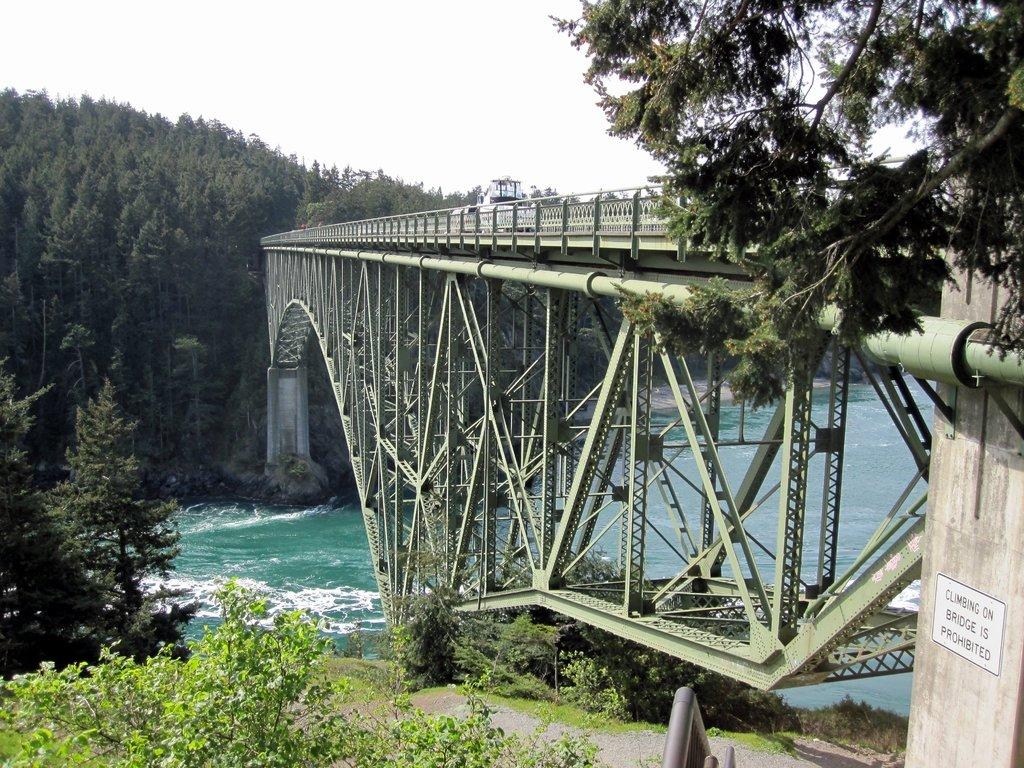What type of structure can be seen in the image? There is a bridge in the image. What is on the wall in the image? There is a poster on a wall in the image. What type of vegetation is present in the image? There are plants and trees in the image. What type of ground surface is visible in the image? There is grass in the image. What natural element is visible in the image? There is water visible in the image. What part of the natural environment is visible in the background of the image? The sky is visible in the background of the image. How many rings can be seen on the bridge in the image? There are no rings present on the bridge in the image. What type of business is being conducted on the bridge in the image? There is no business activity depicted on the bridge in the image. 